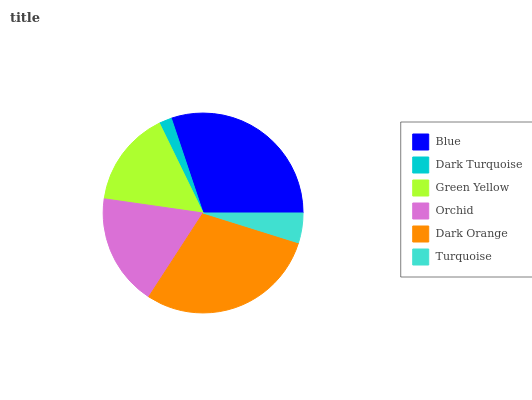Is Dark Turquoise the minimum?
Answer yes or no. Yes. Is Blue the maximum?
Answer yes or no. Yes. Is Green Yellow the minimum?
Answer yes or no. No. Is Green Yellow the maximum?
Answer yes or no. No. Is Green Yellow greater than Dark Turquoise?
Answer yes or no. Yes. Is Dark Turquoise less than Green Yellow?
Answer yes or no. Yes. Is Dark Turquoise greater than Green Yellow?
Answer yes or no. No. Is Green Yellow less than Dark Turquoise?
Answer yes or no. No. Is Orchid the high median?
Answer yes or no. Yes. Is Green Yellow the low median?
Answer yes or no. Yes. Is Dark Orange the high median?
Answer yes or no. No. Is Dark Turquoise the low median?
Answer yes or no. No. 